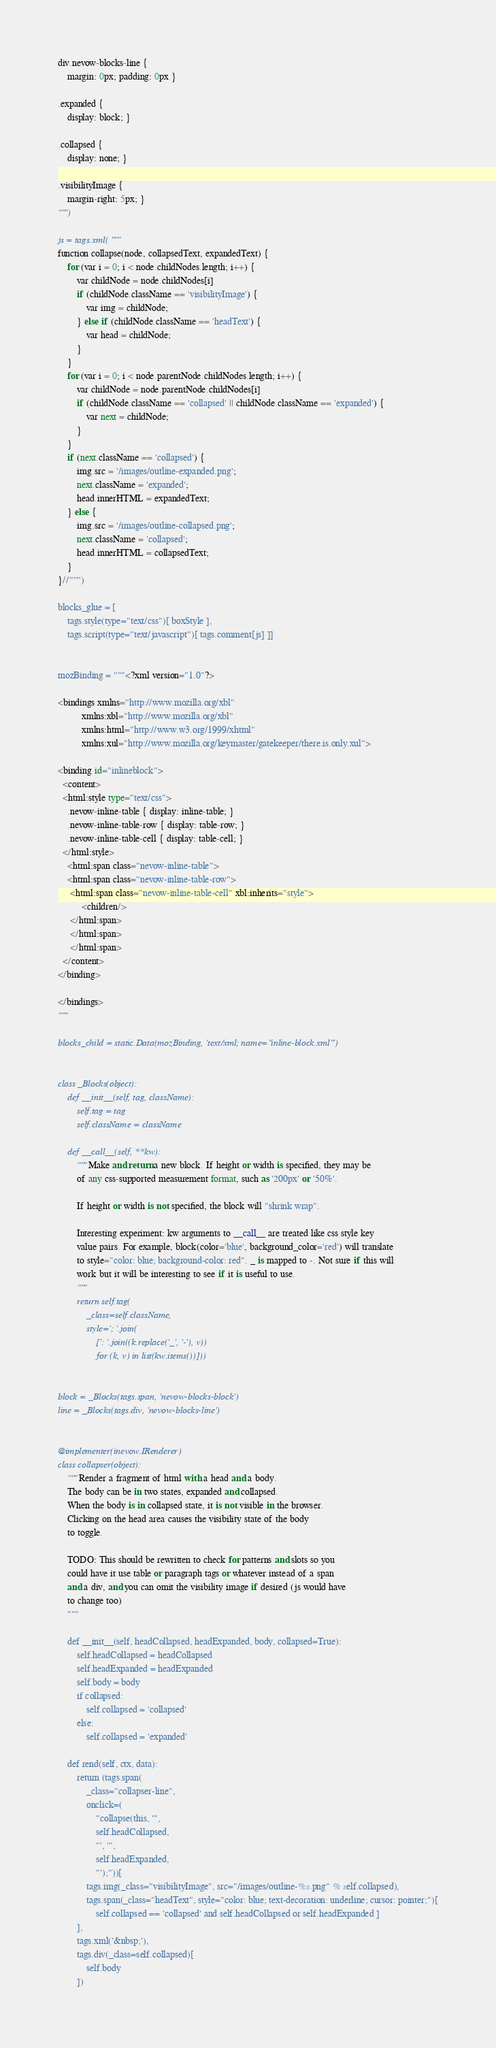Convert code to text. <code><loc_0><loc_0><loc_500><loc_500><_Python_>
div.nevow-blocks-line {
    margin: 0px; padding: 0px }

.expanded {
    display: block; }

.collapsed {
    display: none; }

.visibilityImage {
    margin-right: 5px; }
""")

js = tags.xml( """
function collapse(node, collapsedText, expandedText) {
    for (var i = 0; i < node.childNodes.length; i++) {
        var childNode = node.childNodes[i]
        if (childNode.className == 'visibilityImage') {
            var img = childNode;
        } else if (childNode.className == 'headText') {
            var head = childNode;
        }
    }
    for (var i = 0; i < node.parentNode.childNodes.length; i++) {
        var childNode = node.parentNode.childNodes[i]
        if (childNode.className == 'collapsed' || childNode.className == 'expanded') {
            var next = childNode;
        }
    }
    if (next.className == 'collapsed') {
        img.src = '/images/outline-expanded.png';
        next.className = 'expanded';
        head.innerHTML = expandedText;
    } else {
        img.src = '/images/outline-collapsed.png';
        next.className = 'collapsed';
        head.innerHTML = collapsedText;
    }
}//""")

blocks_glue = [
    tags.style(type="text/css")[ boxStyle ],
    tags.script(type="text/javascript")[ tags.comment[js] ]]


mozBinding = """<?xml version="1.0"?>

<bindings xmlns="http://www.mozilla.org/xbl"
          xmlns:xbl="http://www.mozilla.org/xbl"
          xmlns:html="http://www.w3.org/1999/xhtml"
          xmlns:xul="http://www.mozilla.org/keymaster/gatekeeper/there.is.only.xul">

<binding id="inlineblock">
  <content>
  <html:style type="text/css">
    .nevow-inline-table { display: inline-table; }
    .nevow-inline-table-row { display: table-row; }
    .nevow-inline-table-cell { display: table-cell; }
  </html:style>
    <html:span class="nevow-inline-table">
    <html:span class="nevow-inline-table-row">
     <html:span class="nevow-inline-table-cell" xbl:inherits="style">
          <children/>
     </html:span>
     </html:span>
     </html:span>
  </content>
</binding>

</bindings>
"""

blocks_child = static.Data(mozBinding, 'text/xml; name="inline-block.xml"')


class _Blocks(object):
    def __init__(self, tag, className):
        self.tag = tag
        self.className = className

    def __call__(self, **kw):
        """Make and return a new block. If height or width is specified, they may be
        of any css-supported measurement format, such as '200px' or '50%'.
        
        If height or width is not specified, the block will "shrink wrap".
        
        Interesting experiment: kw arguments to __call__ are treated like css style key
        value pairs. For example, block(color='blue', background_color='red') will translate
        to style="color: blue; background-color: red". _ is mapped to -. Not sure if this will
        work but it will be interesting to see if it is useful to use.
        """
        return self.tag(
            _class=self.className,
            style='; '.join(
                [': '.join((k.replace('_', '-'), v))
                for (k, v) in list(kw.items())]))


block = _Blocks(tags.span, 'nevow-blocks-block')
line = _Blocks(tags.div, 'nevow-blocks-line')


@implementer(inevow.IRenderer)
class collapser(object):
    """Render a fragment of html with a head and a body.
    The body can be in two states, expanded and collapsed.
    When the body is in collapsed state, it is not visible in the browser.
    Clicking on the head area causes the visibility state of the body
    to toggle.

    TODO: This should be rewritten to check for patterns and slots so you
    could have it use table or paragraph tags or whatever instead of a span
    and a div, and you can omit the visibility image if desired (js would have 
    to change too)
    """

    def __init__(self, headCollapsed, headExpanded, body, collapsed=True):
        self.headCollapsed = headCollapsed
        self.headExpanded = headExpanded
        self.body = body
        if collapsed:
            self.collapsed = 'collapsed'
        else:
            self.collapsed = 'expanded'

    def rend(self, ctx, data):
        return (tags.span(
            _class="collapser-line",
            onclick=(
                "collapse(this, '",
                self.headCollapsed,
                "', '",
                self.headExpanded,
                "');"))[
            tags.img(_class="visibilityImage", src="/images/outline-%s.png" % self.collapsed),
            tags.span(_class="headText", style="color: blue; text-decoration: underline; cursor: pointer;")[
                self.collapsed == 'collapsed' and self.headCollapsed or self.headExpanded ]
        ],
        tags.xml('&nbsp;'),
        tags.div(_class=self.collapsed)[
            self.body
        ])

</code> 